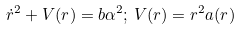Convert formula to latex. <formula><loc_0><loc_0><loc_500><loc_500>\dot { r } ^ { 2 } + V ( r ) = b \alpha ^ { 2 } ; \, V ( r ) = r ^ { 2 } a ( r )</formula> 